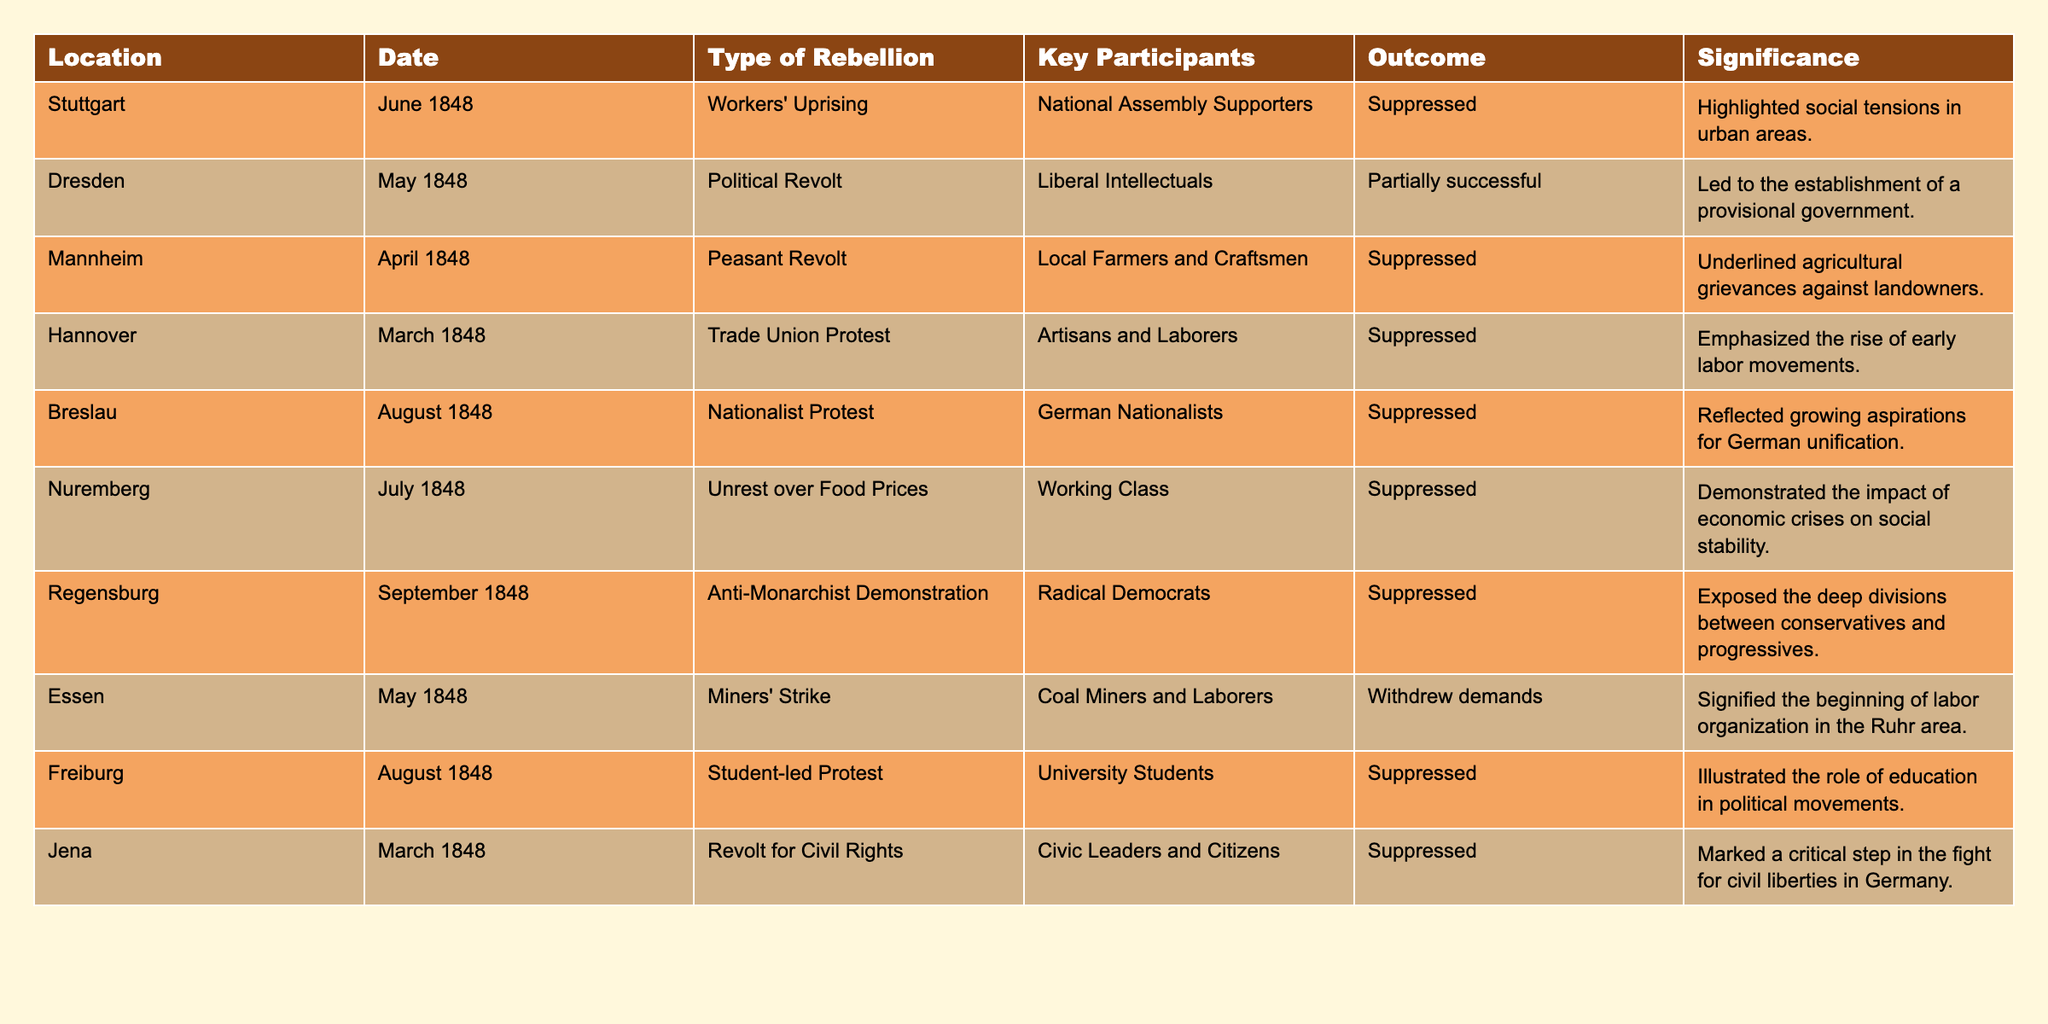What rebellion took place in Dresden in May 1848? According to the table, the rebellion that took place in Dresden in May 1848 was a Political Revolt, which involved Liberal Intellectuals as key participants.
Answer: Political Revolt What was the outcome of the workers' uprising in Stuttgart? The table indicates that the workers' uprising in Stuttgart was suppressed.
Answer: Suppressed How many rebellions were categorized as suppressed? By reviewing the table, we can see that out of the listed rebellions, six were marked as suppressed.
Answer: Six Which type of rebellion occurred in Essen in May 1848? The table shows that the type of rebellion in Essen in May 1848 was a Miners' Strike.
Answer: Miners' Strike What was the significance of the peasant revolt in Mannheim? The table states that the significance of the peasant revolt in Mannheim was that it underlined agricultural grievances against landowners.
Answer: Agricultural grievances Did any of the rebellions lead to a completely successful outcome? The table shows that none of the rebellions had a completely successful outcome; two were partially successful while the rest were suppressed.
Answer: No Which rebellion had the participation of university students? According to the table, the student-led protest in Freiburg had university students among its key participants.
Answer: Student-led protest in Freiburg What was the date of the anti-monarchist demonstration in Regensburg? The table indicates that the anti-monarchist demonstration in Regensburg took place in September 1848.
Answer: September 1848 Which rebellion highlighted social tensions in urban areas? The Stuttgart workers' uprising highlighted social tensions in urban areas as per the information provided in the table.
Answer: Stuttgart workers' uprising What common characteristic is shared by the rebellions in Hannover and Essen? Both the rebellions in Hannover (Trade Union Protest) and Essen (Miners' Strike) involved early labor movements and were against prevailing economic conditions.
Answer: Involvement in early labor movements 